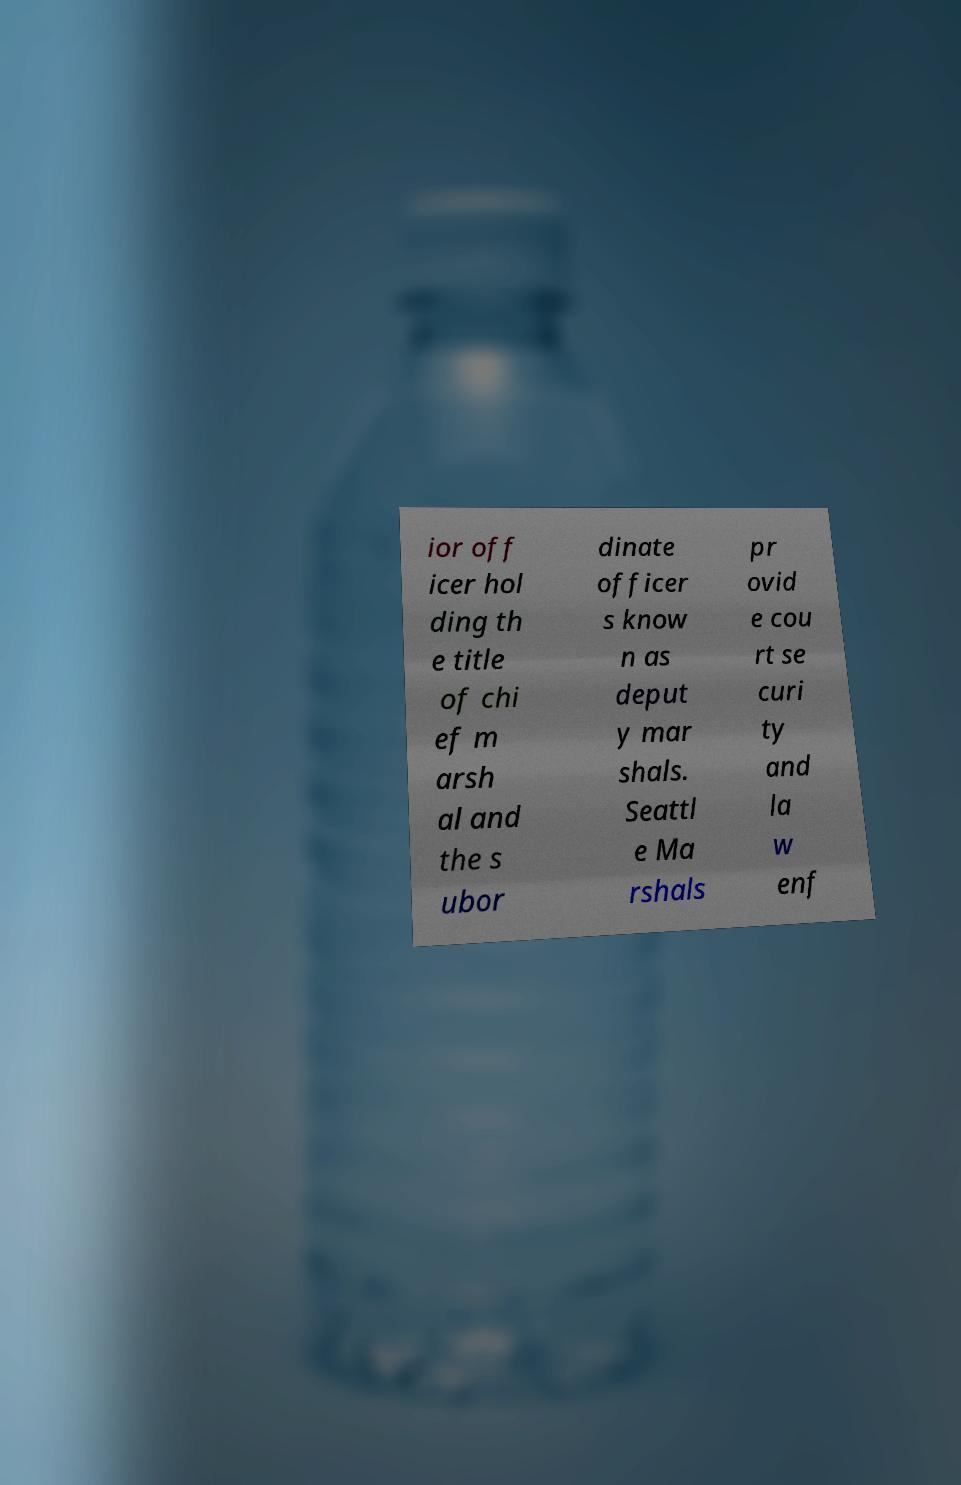Could you assist in decoding the text presented in this image and type it out clearly? ior off icer hol ding th e title of chi ef m arsh al and the s ubor dinate officer s know n as deput y mar shals. Seattl e Ma rshals pr ovid e cou rt se curi ty and la w enf 